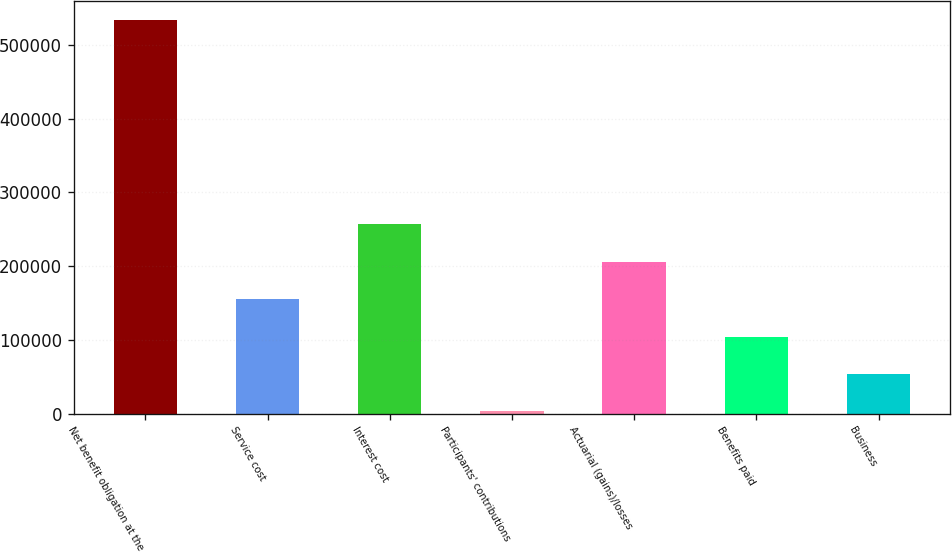Convert chart to OTSL. <chart><loc_0><loc_0><loc_500><loc_500><bar_chart><fcel>Net benefit obligation at the<fcel>Service cost<fcel>Interest cost<fcel>Participants' contributions<fcel>Actuarial (gains)/losses<fcel>Benefits paid<fcel>Business<nl><fcel>533182<fcel>155122<fcel>256402<fcel>3200<fcel>205762<fcel>104481<fcel>53840.5<nl></chart> 